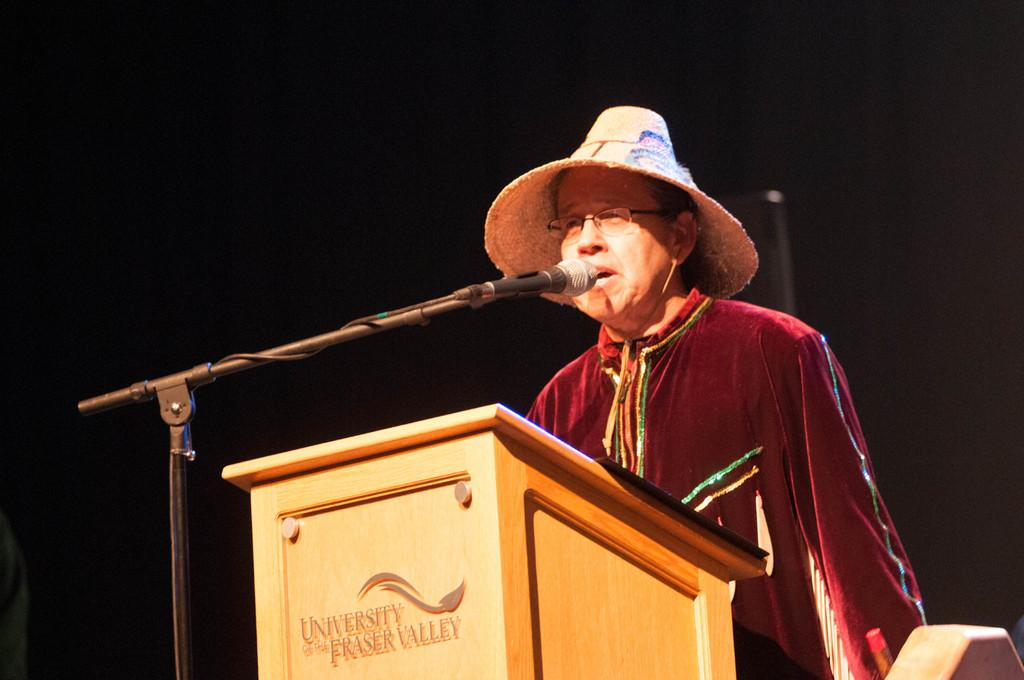Who is present in the image? There is a person in the image. What is the person wearing on their head? The person is wearing a hat. What is the person doing in the image? The person is talking. What object is in front of the person? There is a podium in front of the person. What device is used for amplifying the person's voice? There is a microphone in the image. What type of support structure is present in the image? There is a stand in the image. What is the color of the person's hat? The color of the person's hat is not mentioned in the facts provided. What type of plant is growing on the person's hat in the image? There is no plant growing on the person's hat in the image. Can you tell me how many toads are sitting on the podium in the image? There are no toads present in the image. 